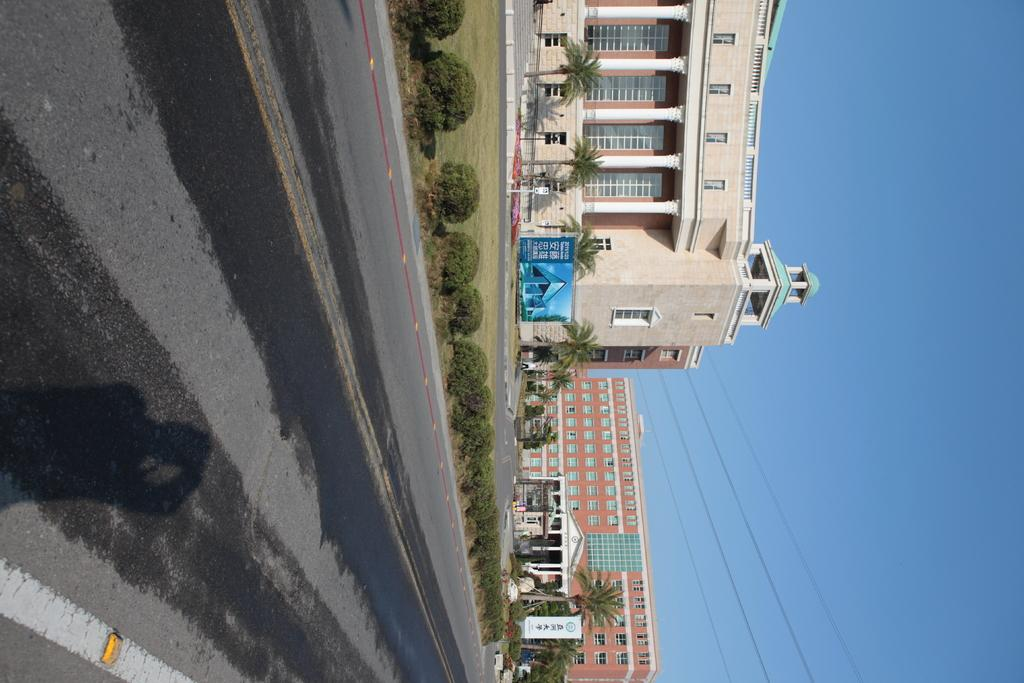What type of structures can be seen in the image? There are buildings in the image. What is happening on the road in the image? Motor vehicles are present on the road, and there are people standing on the road in the image. What type of vegetation is visible in the image? Shrubs and trees are present in the image. What else can be seen in the image besides the buildings and vegetation? Electric cables are visible in the image. What is visible at the top of the image? The sky is visible in the image. Can you tell me how many gates are present in the image? There are no gates present in the image. What type of show is happening on the road in the image? There is no show happening on the road in the image; it shows motor vehicles and people standing on the road. 